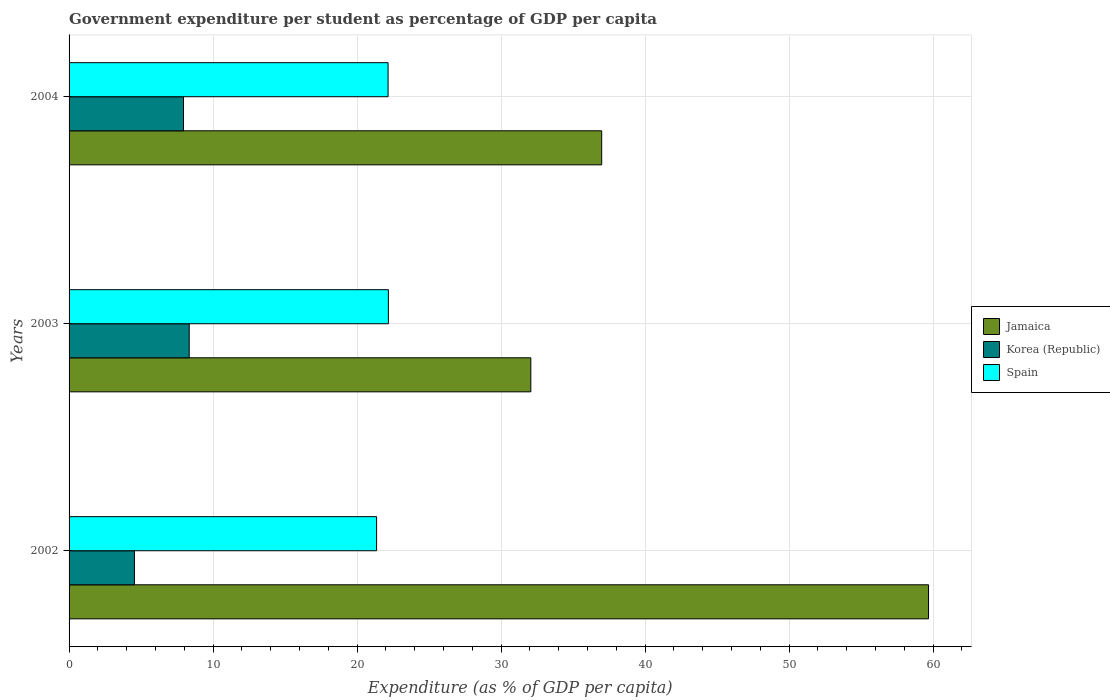How many different coloured bars are there?
Offer a terse response. 3. Are the number of bars per tick equal to the number of legend labels?
Your response must be concise. Yes. What is the percentage of expenditure per student in Jamaica in 2004?
Your answer should be compact. 36.99. Across all years, what is the maximum percentage of expenditure per student in Korea (Republic)?
Your answer should be compact. 8.34. Across all years, what is the minimum percentage of expenditure per student in Korea (Republic)?
Your answer should be very brief. 4.54. What is the total percentage of expenditure per student in Korea (Republic) in the graph?
Your response must be concise. 20.83. What is the difference between the percentage of expenditure per student in Jamaica in 2002 and that in 2004?
Make the answer very short. 22.7. What is the difference between the percentage of expenditure per student in Jamaica in 2003 and the percentage of expenditure per student in Spain in 2002?
Give a very brief answer. 10.71. What is the average percentage of expenditure per student in Spain per year?
Provide a succinct answer. 21.9. In the year 2002, what is the difference between the percentage of expenditure per student in Jamaica and percentage of expenditure per student in Spain?
Your answer should be compact. 38.33. In how many years, is the percentage of expenditure per student in Spain greater than 16 %?
Ensure brevity in your answer.  3. What is the ratio of the percentage of expenditure per student in Spain in 2002 to that in 2004?
Offer a very short reply. 0.96. Is the percentage of expenditure per student in Spain in 2002 less than that in 2003?
Offer a very short reply. Yes. Is the difference between the percentage of expenditure per student in Jamaica in 2003 and 2004 greater than the difference between the percentage of expenditure per student in Spain in 2003 and 2004?
Offer a terse response. No. What is the difference between the highest and the second highest percentage of expenditure per student in Korea (Republic)?
Make the answer very short. 0.4. What is the difference between the highest and the lowest percentage of expenditure per student in Korea (Republic)?
Give a very brief answer. 3.81. What does the 2nd bar from the top in 2003 represents?
Offer a very short reply. Korea (Republic). What does the 2nd bar from the bottom in 2002 represents?
Provide a succinct answer. Korea (Republic). Are all the bars in the graph horizontal?
Ensure brevity in your answer.  Yes. Does the graph contain any zero values?
Give a very brief answer. No. What is the title of the graph?
Your answer should be very brief. Government expenditure per student as percentage of GDP per capita. What is the label or title of the X-axis?
Offer a very short reply. Expenditure (as % of GDP per capita). What is the Expenditure (as % of GDP per capita) of Jamaica in 2002?
Give a very brief answer. 59.69. What is the Expenditure (as % of GDP per capita) in Korea (Republic) in 2002?
Your answer should be very brief. 4.54. What is the Expenditure (as % of GDP per capita) in Spain in 2002?
Offer a very short reply. 21.36. What is the Expenditure (as % of GDP per capita) of Jamaica in 2003?
Give a very brief answer. 32.07. What is the Expenditure (as % of GDP per capita) in Korea (Republic) in 2003?
Ensure brevity in your answer.  8.34. What is the Expenditure (as % of GDP per capita) in Spain in 2003?
Your response must be concise. 22.18. What is the Expenditure (as % of GDP per capita) in Jamaica in 2004?
Provide a succinct answer. 36.99. What is the Expenditure (as % of GDP per capita) in Korea (Republic) in 2004?
Ensure brevity in your answer.  7.95. What is the Expenditure (as % of GDP per capita) in Spain in 2004?
Your answer should be very brief. 22.16. Across all years, what is the maximum Expenditure (as % of GDP per capita) in Jamaica?
Your answer should be compact. 59.69. Across all years, what is the maximum Expenditure (as % of GDP per capita) of Korea (Republic)?
Make the answer very short. 8.34. Across all years, what is the maximum Expenditure (as % of GDP per capita) of Spain?
Your answer should be compact. 22.18. Across all years, what is the minimum Expenditure (as % of GDP per capita) of Jamaica?
Offer a terse response. 32.07. Across all years, what is the minimum Expenditure (as % of GDP per capita) in Korea (Republic)?
Provide a succinct answer. 4.54. Across all years, what is the minimum Expenditure (as % of GDP per capita) of Spain?
Keep it short and to the point. 21.36. What is the total Expenditure (as % of GDP per capita) in Jamaica in the graph?
Offer a very short reply. 128.75. What is the total Expenditure (as % of GDP per capita) in Korea (Republic) in the graph?
Provide a succinct answer. 20.83. What is the total Expenditure (as % of GDP per capita) in Spain in the graph?
Your response must be concise. 65.69. What is the difference between the Expenditure (as % of GDP per capita) in Jamaica in 2002 and that in 2003?
Make the answer very short. 27.62. What is the difference between the Expenditure (as % of GDP per capita) in Korea (Republic) in 2002 and that in 2003?
Ensure brevity in your answer.  -3.81. What is the difference between the Expenditure (as % of GDP per capita) in Spain in 2002 and that in 2003?
Offer a terse response. -0.82. What is the difference between the Expenditure (as % of GDP per capita) in Jamaica in 2002 and that in 2004?
Your response must be concise. 22.7. What is the difference between the Expenditure (as % of GDP per capita) in Korea (Republic) in 2002 and that in 2004?
Offer a very short reply. -3.41. What is the difference between the Expenditure (as % of GDP per capita) of Spain in 2002 and that in 2004?
Your answer should be very brief. -0.8. What is the difference between the Expenditure (as % of GDP per capita) of Jamaica in 2003 and that in 2004?
Your response must be concise. -4.92. What is the difference between the Expenditure (as % of GDP per capita) of Korea (Republic) in 2003 and that in 2004?
Offer a terse response. 0.4. What is the difference between the Expenditure (as % of GDP per capita) of Spain in 2003 and that in 2004?
Keep it short and to the point. 0.02. What is the difference between the Expenditure (as % of GDP per capita) of Jamaica in 2002 and the Expenditure (as % of GDP per capita) of Korea (Republic) in 2003?
Your answer should be compact. 51.34. What is the difference between the Expenditure (as % of GDP per capita) in Jamaica in 2002 and the Expenditure (as % of GDP per capita) in Spain in 2003?
Your answer should be very brief. 37.51. What is the difference between the Expenditure (as % of GDP per capita) in Korea (Republic) in 2002 and the Expenditure (as % of GDP per capita) in Spain in 2003?
Provide a succinct answer. -17.64. What is the difference between the Expenditure (as % of GDP per capita) in Jamaica in 2002 and the Expenditure (as % of GDP per capita) in Korea (Republic) in 2004?
Provide a short and direct response. 51.74. What is the difference between the Expenditure (as % of GDP per capita) in Jamaica in 2002 and the Expenditure (as % of GDP per capita) in Spain in 2004?
Ensure brevity in your answer.  37.53. What is the difference between the Expenditure (as % of GDP per capita) in Korea (Republic) in 2002 and the Expenditure (as % of GDP per capita) in Spain in 2004?
Give a very brief answer. -17.62. What is the difference between the Expenditure (as % of GDP per capita) of Jamaica in 2003 and the Expenditure (as % of GDP per capita) of Korea (Republic) in 2004?
Ensure brevity in your answer.  24.12. What is the difference between the Expenditure (as % of GDP per capita) of Jamaica in 2003 and the Expenditure (as % of GDP per capita) of Spain in 2004?
Your response must be concise. 9.91. What is the difference between the Expenditure (as % of GDP per capita) of Korea (Republic) in 2003 and the Expenditure (as % of GDP per capita) of Spain in 2004?
Offer a very short reply. -13.81. What is the average Expenditure (as % of GDP per capita) in Jamaica per year?
Provide a short and direct response. 42.92. What is the average Expenditure (as % of GDP per capita) of Korea (Republic) per year?
Your response must be concise. 6.94. What is the average Expenditure (as % of GDP per capita) in Spain per year?
Give a very brief answer. 21.9. In the year 2002, what is the difference between the Expenditure (as % of GDP per capita) of Jamaica and Expenditure (as % of GDP per capita) of Korea (Republic)?
Give a very brief answer. 55.15. In the year 2002, what is the difference between the Expenditure (as % of GDP per capita) of Jamaica and Expenditure (as % of GDP per capita) of Spain?
Offer a terse response. 38.33. In the year 2002, what is the difference between the Expenditure (as % of GDP per capita) in Korea (Republic) and Expenditure (as % of GDP per capita) in Spain?
Your answer should be compact. -16.82. In the year 2003, what is the difference between the Expenditure (as % of GDP per capita) of Jamaica and Expenditure (as % of GDP per capita) of Korea (Republic)?
Make the answer very short. 23.72. In the year 2003, what is the difference between the Expenditure (as % of GDP per capita) in Jamaica and Expenditure (as % of GDP per capita) in Spain?
Keep it short and to the point. 9.89. In the year 2003, what is the difference between the Expenditure (as % of GDP per capita) in Korea (Republic) and Expenditure (as % of GDP per capita) in Spain?
Ensure brevity in your answer.  -13.83. In the year 2004, what is the difference between the Expenditure (as % of GDP per capita) of Jamaica and Expenditure (as % of GDP per capita) of Korea (Republic)?
Provide a short and direct response. 29.04. In the year 2004, what is the difference between the Expenditure (as % of GDP per capita) in Jamaica and Expenditure (as % of GDP per capita) in Spain?
Your answer should be compact. 14.84. In the year 2004, what is the difference between the Expenditure (as % of GDP per capita) of Korea (Republic) and Expenditure (as % of GDP per capita) of Spain?
Provide a succinct answer. -14.21. What is the ratio of the Expenditure (as % of GDP per capita) in Jamaica in 2002 to that in 2003?
Your answer should be compact. 1.86. What is the ratio of the Expenditure (as % of GDP per capita) of Korea (Republic) in 2002 to that in 2003?
Ensure brevity in your answer.  0.54. What is the ratio of the Expenditure (as % of GDP per capita) of Spain in 2002 to that in 2003?
Provide a short and direct response. 0.96. What is the ratio of the Expenditure (as % of GDP per capita) of Jamaica in 2002 to that in 2004?
Your answer should be very brief. 1.61. What is the ratio of the Expenditure (as % of GDP per capita) of Korea (Republic) in 2002 to that in 2004?
Offer a very short reply. 0.57. What is the ratio of the Expenditure (as % of GDP per capita) in Spain in 2002 to that in 2004?
Provide a short and direct response. 0.96. What is the ratio of the Expenditure (as % of GDP per capita) of Jamaica in 2003 to that in 2004?
Your response must be concise. 0.87. What is the ratio of the Expenditure (as % of GDP per capita) of Korea (Republic) in 2003 to that in 2004?
Your answer should be compact. 1.05. What is the ratio of the Expenditure (as % of GDP per capita) in Spain in 2003 to that in 2004?
Provide a short and direct response. 1. What is the difference between the highest and the second highest Expenditure (as % of GDP per capita) of Jamaica?
Your response must be concise. 22.7. What is the difference between the highest and the second highest Expenditure (as % of GDP per capita) in Korea (Republic)?
Make the answer very short. 0.4. What is the difference between the highest and the second highest Expenditure (as % of GDP per capita) of Spain?
Provide a short and direct response. 0.02. What is the difference between the highest and the lowest Expenditure (as % of GDP per capita) in Jamaica?
Provide a short and direct response. 27.62. What is the difference between the highest and the lowest Expenditure (as % of GDP per capita) in Korea (Republic)?
Offer a very short reply. 3.81. What is the difference between the highest and the lowest Expenditure (as % of GDP per capita) in Spain?
Your response must be concise. 0.82. 